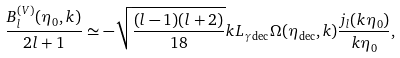Convert formula to latex. <formula><loc_0><loc_0><loc_500><loc_500>\frac { B ^ { ( V ) } _ { l } ( \eta _ { 0 } , k ) } { 2 l + 1 } \simeq - \sqrt { \frac { ( l - 1 ) ( l + 2 ) } { 1 8 } } k L _ { \gamma \, \text {dec} } \Omega ( \eta _ { \text {dec} } , k ) \frac { j _ { l } ( k \eta _ { 0 } ) } { k \eta _ { 0 } } ,</formula> 